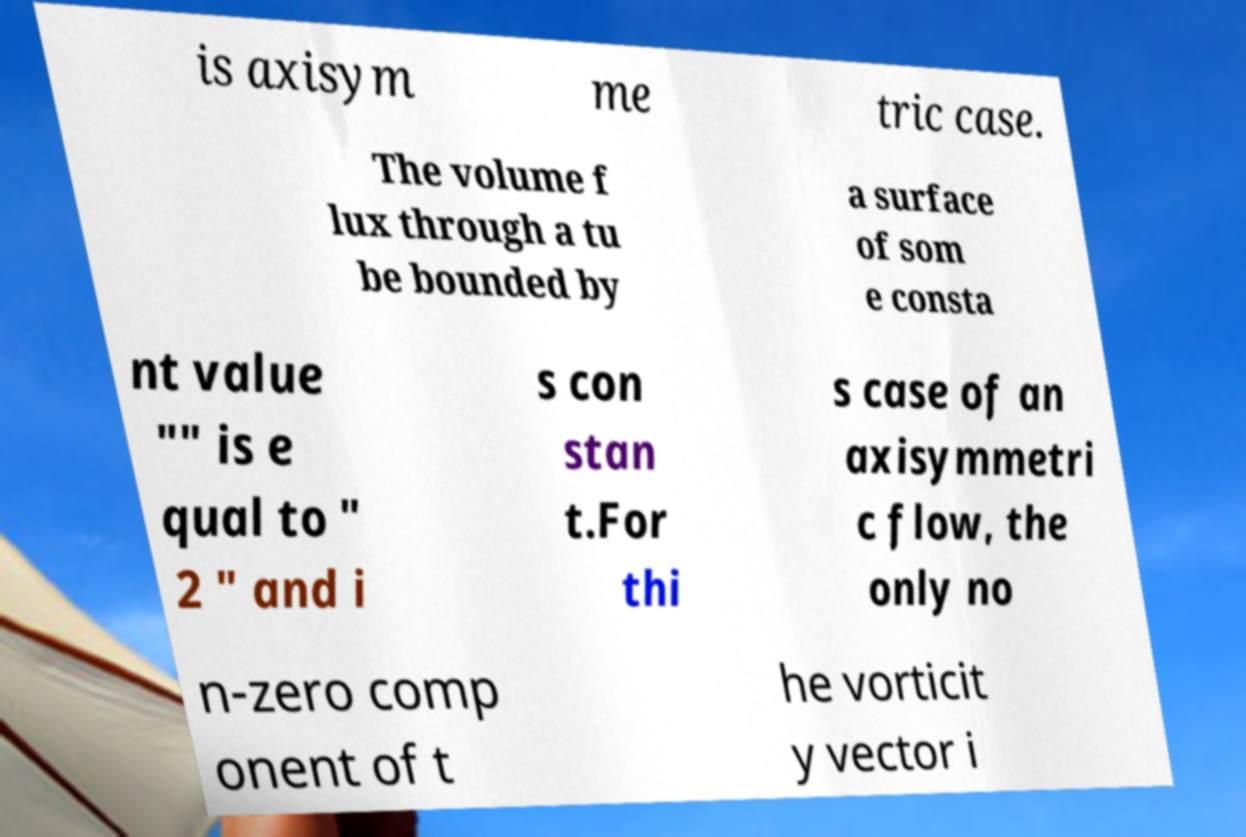What messages or text are displayed in this image? I need them in a readable, typed format. is axisym me tric case. The volume f lux through a tu be bounded by a surface of som e consta nt value "" is e qual to " 2 " and i s con stan t.For thi s case of an axisymmetri c flow, the only no n-zero comp onent of t he vorticit y vector i 